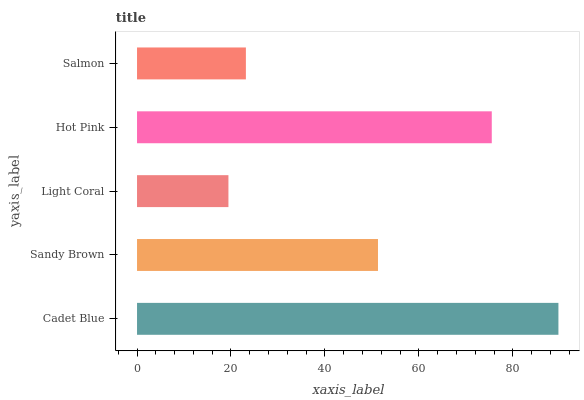Is Light Coral the minimum?
Answer yes or no. Yes. Is Cadet Blue the maximum?
Answer yes or no. Yes. Is Sandy Brown the minimum?
Answer yes or no. No. Is Sandy Brown the maximum?
Answer yes or no. No. Is Cadet Blue greater than Sandy Brown?
Answer yes or no. Yes. Is Sandy Brown less than Cadet Blue?
Answer yes or no. Yes. Is Sandy Brown greater than Cadet Blue?
Answer yes or no. No. Is Cadet Blue less than Sandy Brown?
Answer yes or no. No. Is Sandy Brown the high median?
Answer yes or no. Yes. Is Sandy Brown the low median?
Answer yes or no. Yes. Is Light Coral the high median?
Answer yes or no. No. Is Light Coral the low median?
Answer yes or no. No. 